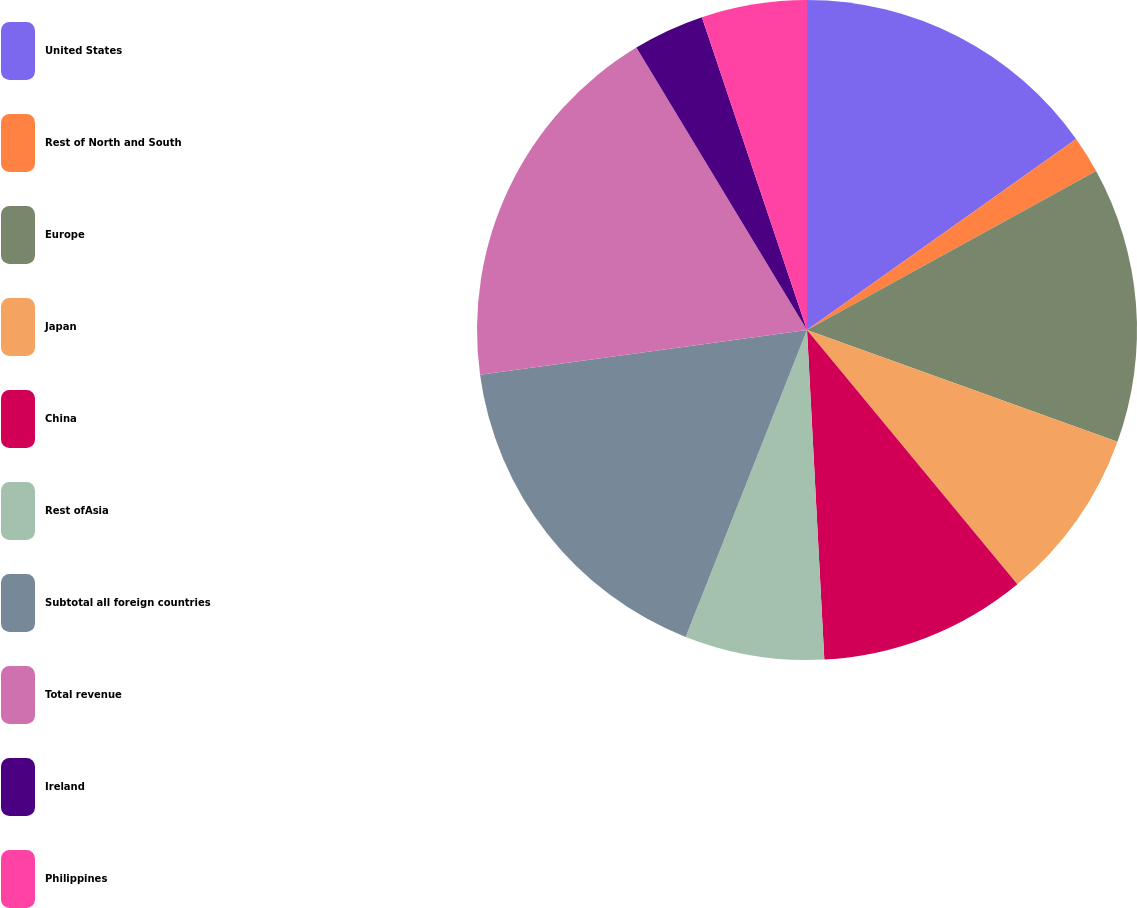Convert chart to OTSL. <chart><loc_0><loc_0><loc_500><loc_500><pie_chart><fcel>United States<fcel>Rest of North and South<fcel>Europe<fcel>Japan<fcel>China<fcel>Rest ofAsia<fcel>Subtotal all foreign countries<fcel>Total revenue<fcel>Ireland<fcel>Philippines<nl><fcel>15.18%<fcel>1.82%<fcel>13.51%<fcel>8.5%<fcel>10.17%<fcel>6.83%<fcel>16.85%<fcel>18.52%<fcel>3.49%<fcel>5.16%<nl></chart> 